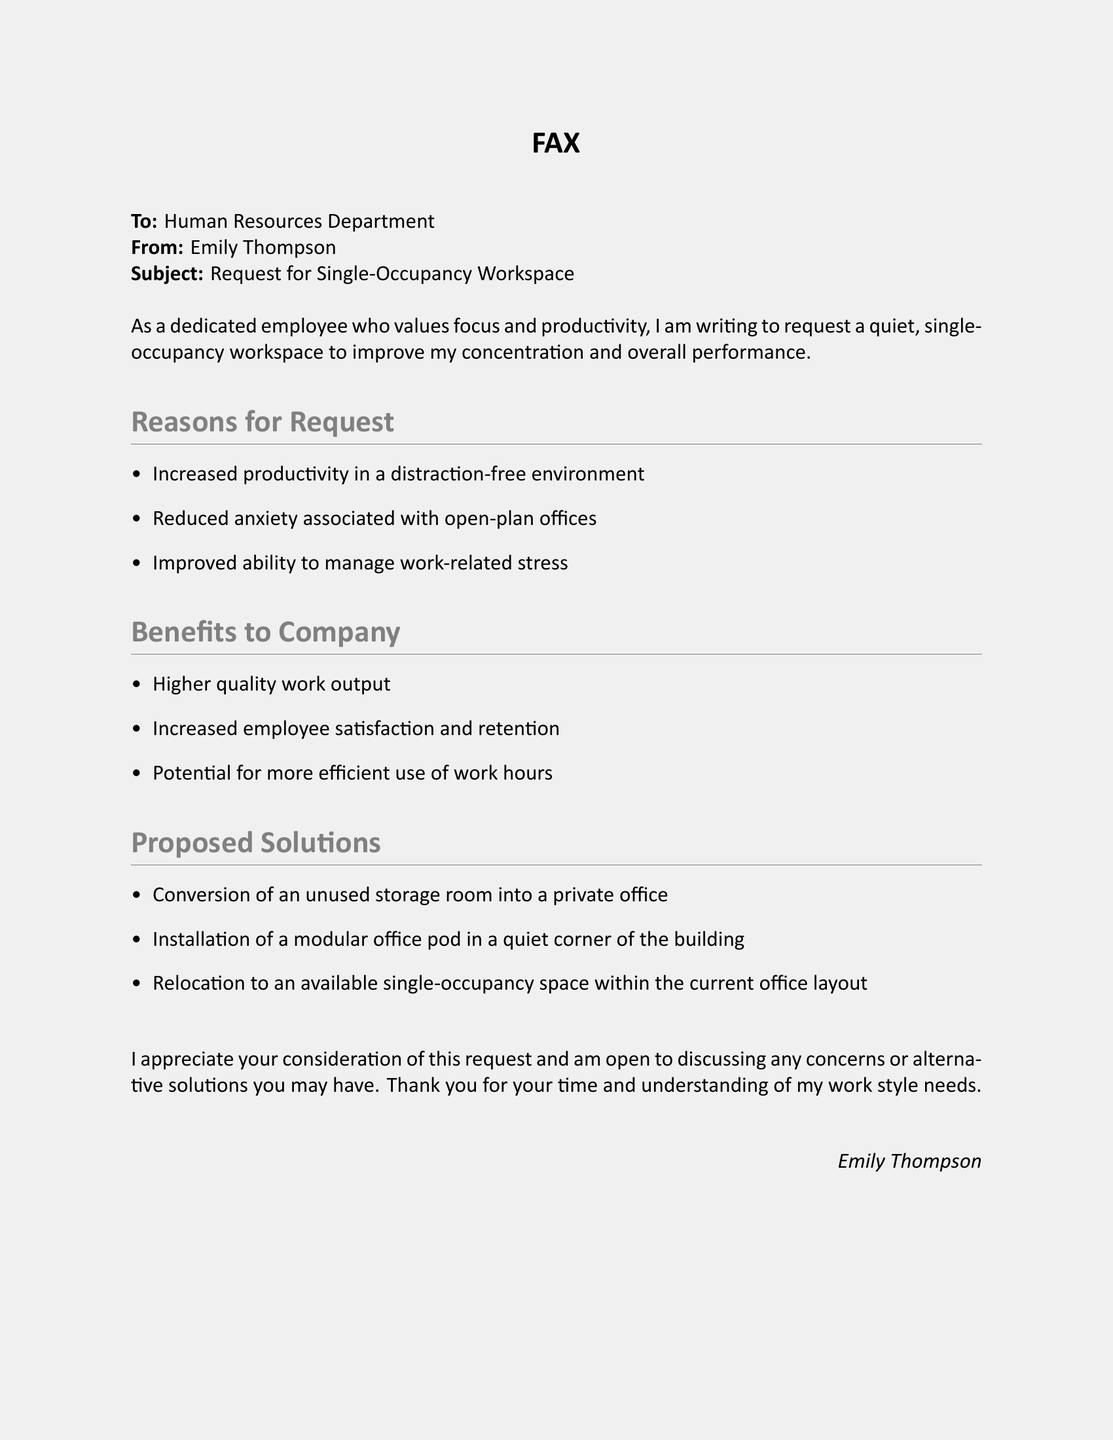What is the recipient department of the fax? The recipient department is identified in the document header as the Human Resources Department.
Answer: Human Resources Department Who is the sender of the fax? The sender's name is clearly mentioned at the top of the document.
Answer: Emily Thompson What is the subject of the fax? The subject line specifies the main topic of the fax.
Answer: Request for Single-Occupancy Workspace How many reasons for the request are listed? The document contains a bulleted list that indicates the number of reasons provided.
Answer: Three What benefit to the company is mentioned regarding employee satisfaction? The document lists specific benefits related to employee satisfaction in a bulleted format.
Answer: Increased employee satisfaction and retention What proposed solution involves installation? A solution involving installation is described in the list of proposed solutions provided in the document.
Answer: Installation of a modular office pod What is the tone of the closing statement in the fax? The closing statement expresses the sender's appreciation and willingness to discuss further, indicating a respectful tone.
Answer: Appreciative Which section outlines the reasons for the request? The reasons for the request are clearly outlined in a specific section of the document, making it easy to identify.
Answer: Reasons for Request How does the sender express their openness to discussion? The sender shows their willingness to engage in a dialogue by offering to discuss concerns or alternatives.
Answer: Open to discussing any concerns or alternative solutions 